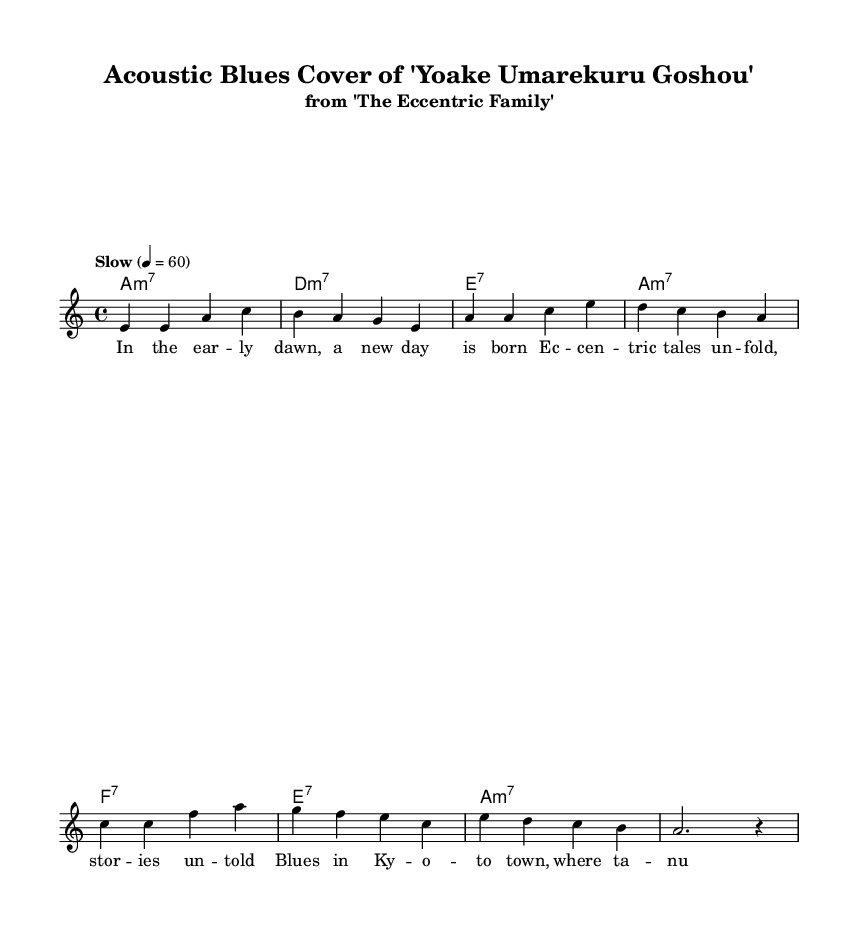What is the key signature of this music? The key signature is A minor, which has no sharps or flats, recognizable by the presence of the 'a' note as the tonic.
Answer: A minor What is the time signature of this piece? The time signature is 4/4, indicated at the beginning of the score, meaning there are four beats in a measure.
Answer: 4/4 What is the tempo marking for this piece? The tempo marking is "Slow," with a metronome mark of 60 beats per minute, suggesting a relaxed pace for the performance.
Answer: Slow How many measures are in the melody? By counting the measures in the melody section, there are a total of 8 measures displayed.
Answer: 8 What is the chord progression used in the harmonies section? The chord progression consists of A minor 7, D minor 7, E7, A minor 7, F7, and E7, as represented in the chord mode.
Answer: A minor 7 - D minor 7 - E7 - A minor 7 - F7 - E7 What style does this music exemplify? The piece exemplifies the blues style, characterized by its slow tempo, distinctive chord progressions, and lyrical theme blending anime and blues.
Answer: Blues 